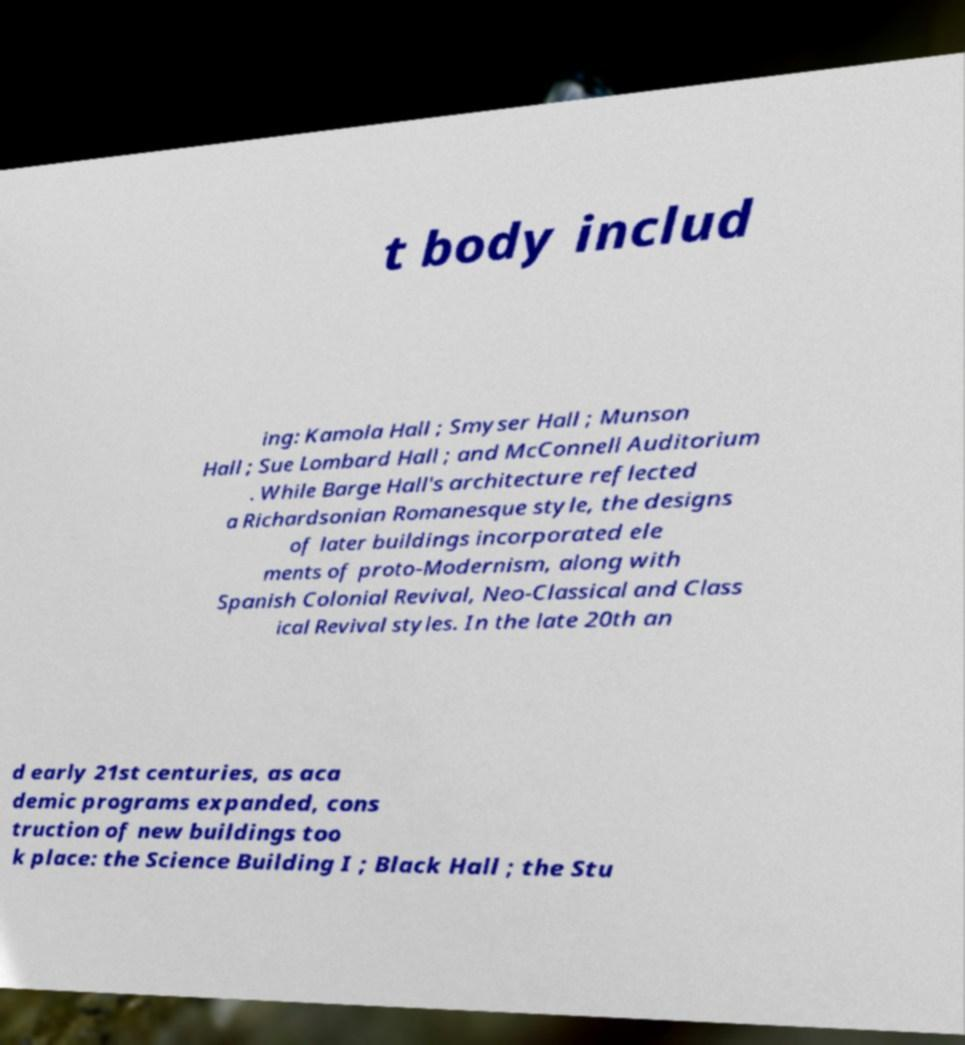I need the written content from this picture converted into text. Can you do that? t body includ ing: Kamola Hall ; Smyser Hall ; Munson Hall ; Sue Lombard Hall ; and McConnell Auditorium . While Barge Hall's architecture reflected a Richardsonian Romanesque style, the designs of later buildings incorporated ele ments of proto-Modernism, along with Spanish Colonial Revival, Neo-Classical and Class ical Revival styles. In the late 20th an d early 21st centuries, as aca demic programs expanded, cons truction of new buildings too k place: the Science Building I ; Black Hall ; the Stu 